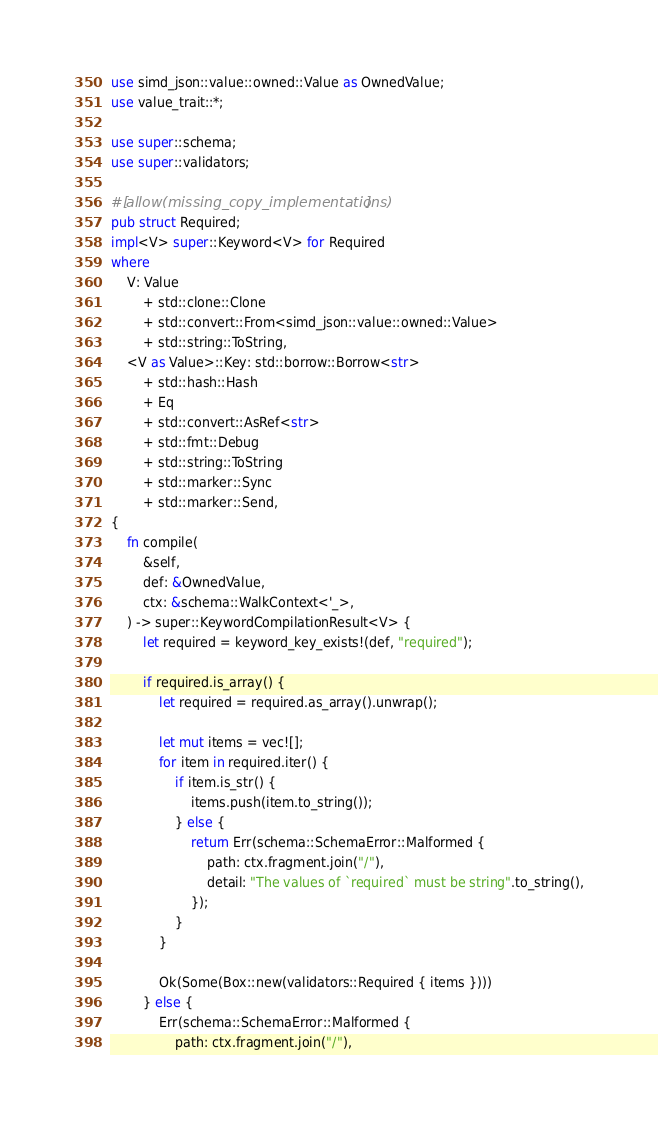Convert code to text. <code><loc_0><loc_0><loc_500><loc_500><_Rust_>use simd_json::value::owned::Value as OwnedValue;
use value_trait::*;

use super::schema;
use super::validators;

#[allow(missing_copy_implementations)]
pub struct Required;
impl<V> super::Keyword<V> for Required
where
    V: Value
        + std::clone::Clone
        + std::convert::From<simd_json::value::owned::Value>
        + std::string::ToString,
    <V as Value>::Key: std::borrow::Borrow<str>
        + std::hash::Hash
        + Eq
        + std::convert::AsRef<str>
        + std::fmt::Debug
        + std::string::ToString
        + std::marker::Sync
        + std::marker::Send,
{
    fn compile(
        &self,
        def: &OwnedValue,
        ctx: &schema::WalkContext<'_>,
    ) -> super::KeywordCompilationResult<V> {
        let required = keyword_key_exists!(def, "required");

        if required.is_array() {
            let required = required.as_array().unwrap();

            let mut items = vec![];
            for item in required.iter() {
                if item.is_str() {
                    items.push(item.to_string());
                } else {
                    return Err(schema::SchemaError::Malformed {
                        path: ctx.fragment.join("/"),
                        detail: "The values of `required` must be string".to_string(),
                    });
                }
            }

            Ok(Some(Box::new(validators::Required { items })))
        } else {
            Err(schema::SchemaError::Malformed {
                path: ctx.fragment.join("/"),</code> 